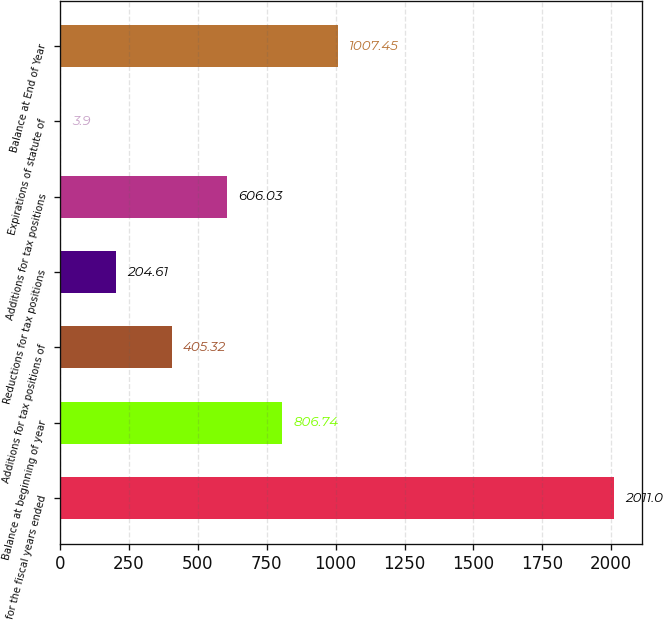Convert chart to OTSL. <chart><loc_0><loc_0><loc_500><loc_500><bar_chart><fcel>for the fiscal years ended<fcel>Balance at beginning of year<fcel>Additions for tax positions of<fcel>Reductions for tax positions<fcel>Additions for tax positions<fcel>Expirations of statute of<fcel>Balance at End of Year<nl><fcel>2011<fcel>806.74<fcel>405.32<fcel>204.61<fcel>606.03<fcel>3.9<fcel>1007.45<nl></chart> 